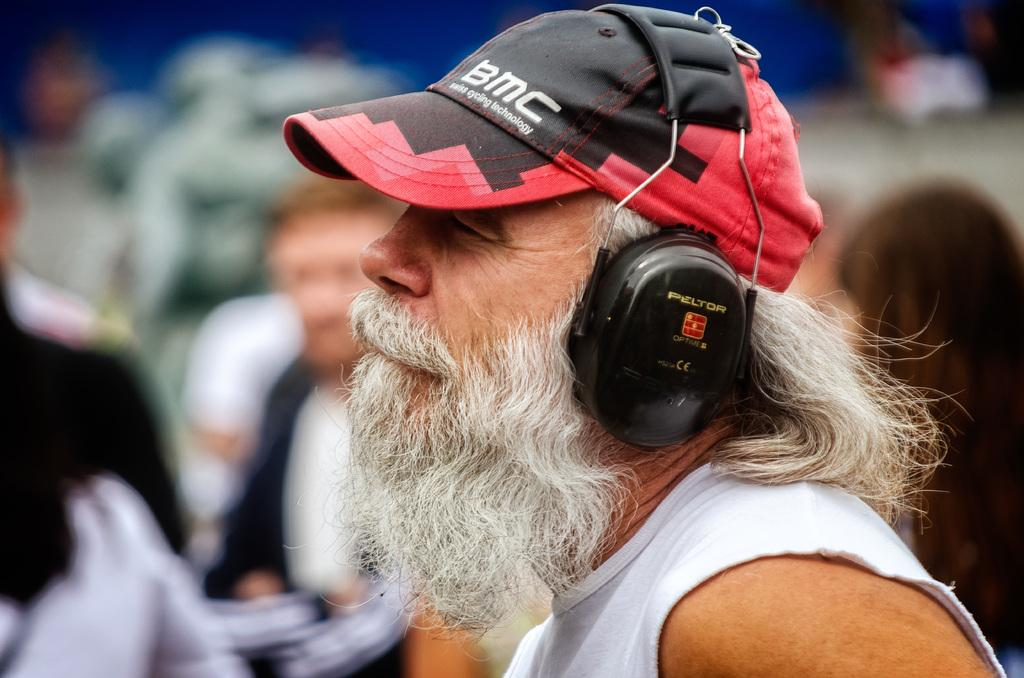What can be seen in the image? There is a person in the image. What is the person wearing on their head? The person is wearing a headset. What type of hat is the person wearing? The person is wearing a cap. Can you describe the background of the image? The background of the image is blurry. How many frogs are serving the person in the image? There are no frogs present in the image, and the person is not being served by any creatures. 